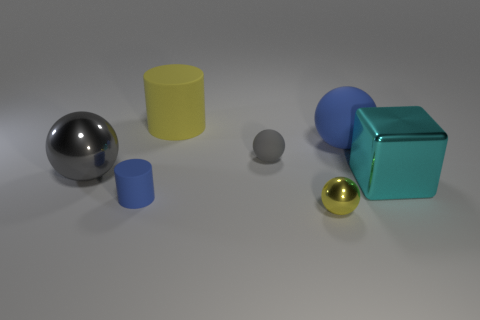Subtract all yellow metal balls. How many balls are left? 3 Subtract 3 balls. How many balls are left? 1 Add 2 big blue blocks. How many objects exist? 9 Subtract all balls. How many objects are left? 3 Subtract all yellow balls. How many balls are left? 3 Subtract all purple cylinders. Subtract all cyan spheres. How many cylinders are left? 2 Subtract all yellow spheres. How many yellow cylinders are left? 1 Subtract all tiny cyan metal things. Subtract all metallic balls. How many objects are left? 5 Add 7 yellow shiny objects. How many yellow shiny objects are left? 8 Add 6 yellow matte blocks. How many yellow matte blocks exist? 6 